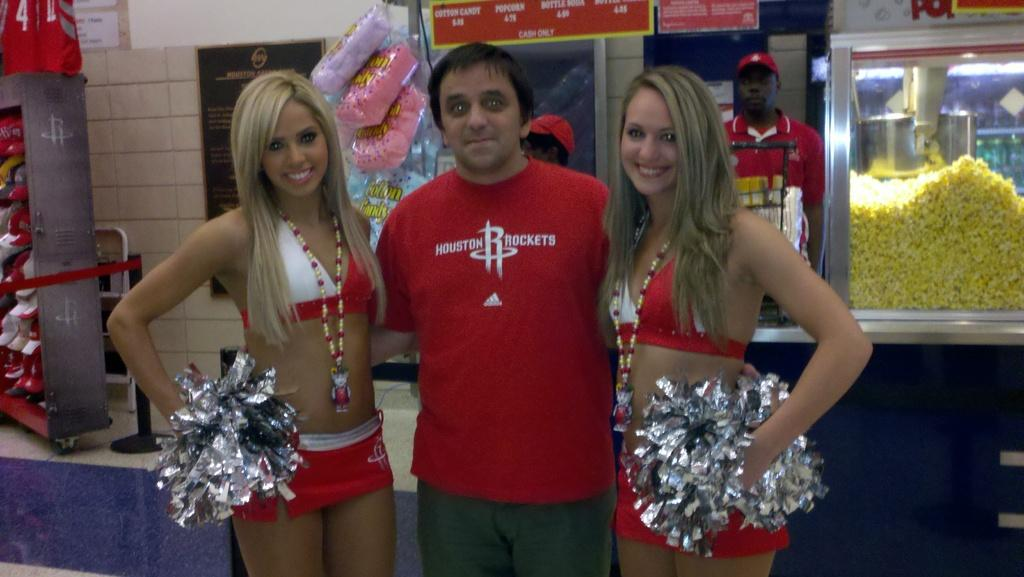<image>
Provide a brief description of the given image. A man between two cheerleaders is wearing a Houston Rockets t-shirt. 